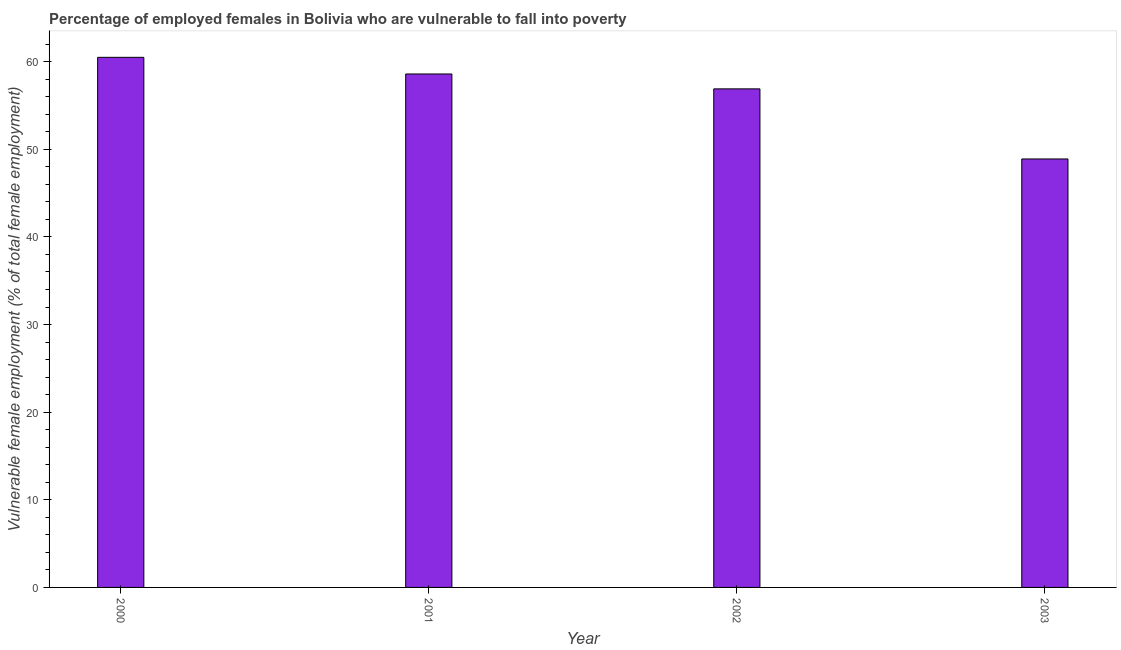Does the graph contain any zero values?
Ensure brevity in your answer.  No. What is the title of the graph?
Provide a short and direct response. Percentage of employed females in Bolivia who are vulnerable to fall into poverty. What is the label or title of the X-axis?
Offer a very short reply. Year. What is the label or title of the Y-axis?
Your answer should be very brief. Vulnerable female employment (% of total female employment). What is the percentage of employed females who are vulnerable to fall into poverty in 2001?
Offer a very short reply. 58.6. Across all years, what is the maximum percentage of employed females who are vulnerable to fall into poverty?
Your answer should be compact. 60.5. Across all years, what is the minimum percentage of employed females who are vulnerable to fall into poverty?
Give a very brief answer. 48.9. In which year was the percentage of employed females who are vulnerable to fall into poverty maximum?
Your response must be concise. 2000. In which year was the percentage of employed females who are vulnerable to fall into poverty minimum?
Offer a very short reply. 2003. What is the sum of the percentage of employed females who are vulnerable to fall into poverty?
Offer a very short reply. 224.9. What is the difference between the percentage of employed females who are vulnerable to fall into poverty in 2001 and 2003?
Provide a short and direct response. 9.7. What is the average percentage of employed females who are vulnerable to fall into poverty per year?
Your answer should be very brief. 56.23. What is the median percentage of employed females who are vulnerable to fall into poverty?
Provide a short and direct response. 57.75. Do a majority of the years between 2000 and 2001 (inclusive) have percentage of employed females who are vulnerable to fall into poverty greater than 56 %?
Offer a very short reply. Yes. What is the difference between the highest and the lowest percentage of employed females who are vulnerable to fall into poverty?
Make the answer very short. 11.6. How many bars are there?
Offer a terse response. 4. How many years are there in the graph?
Provide a short and direct response. 4. What is the difference between two consecutive major ticks on the Y-axis?
Offer a very short reply. 10. What is the Vulnerable female employment (% of total female employment) in 2000?
Offer a very short reply. 60.5. What is the Vulnerable female employment (% of total female employment) of 2001?
Give a very brief answer. 58.6. What is the Vulnerable female employment (% of total female employment) in 2002?
Your response must be concise. 56.9. What is the Vulnerable female employment (% of total female employment) in 2003?
Your response must be concise. 48.9. What is the difference between the Vulnerable female employment (% of total female employment) in 2001 and 2003?
Keep it short and to the point. 9.7. What is the difference between the Vulnerable female employment (% of total female employment) in 2002 and 2003?
Provide a short and direct response. 8. What is the ratio of the Vulnerable female employment (% of total female employment) in 2000 to that in 2001?
Give a very brief answer. 1.03. What is the ratio of the Vulnerable female employment (% of total female employment) in 2000 to that in 2002?
Keep it short and to the point. 1.06. What is the ratio of the Vulnerable female employment (% of total female employment) in 2000 to that in 2003?
Offer a very short reply. 1.24. What is the ratio of the Vulnerable female employment (% of total female employment) in 2001 to that in 2003?
Your answer should be compact. 1.2. What is the ratio of the Vulnerable female employment (% of total female employment) in 2002 to that in 2003?
Provide a succinct answer. 1.16. 